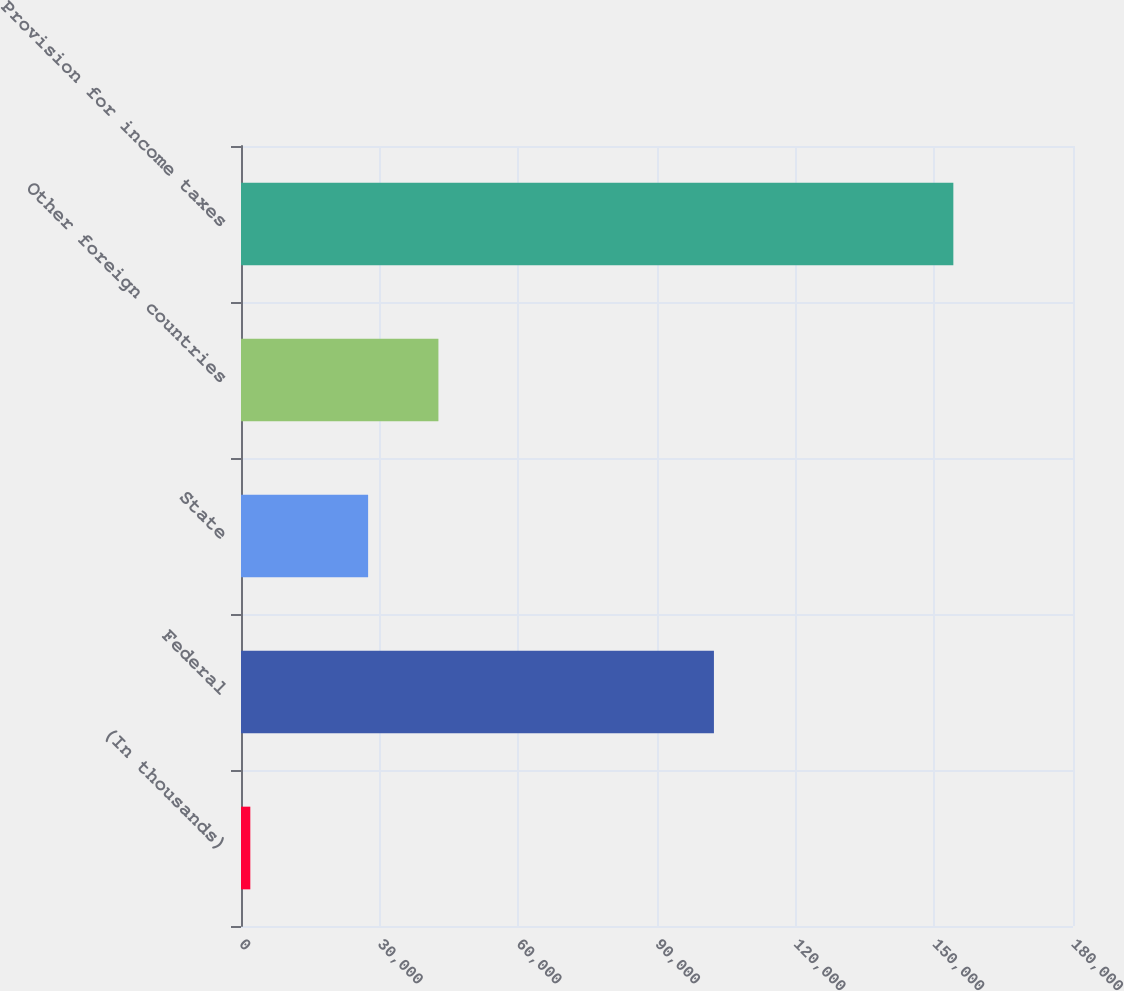Convert chart to OTSL. <chart><loc_0><loc_0><loc_500><loc_500><bar_chart><fcel>(In thousands)<fcel>Federal<fcel>State<fcel>Other foreign countries<fcel>Provision for income taxes<nl><fcel>2015<fcel>102317<fcel>27500<fcel>42709.7<fcel>154112<nl></chart> 